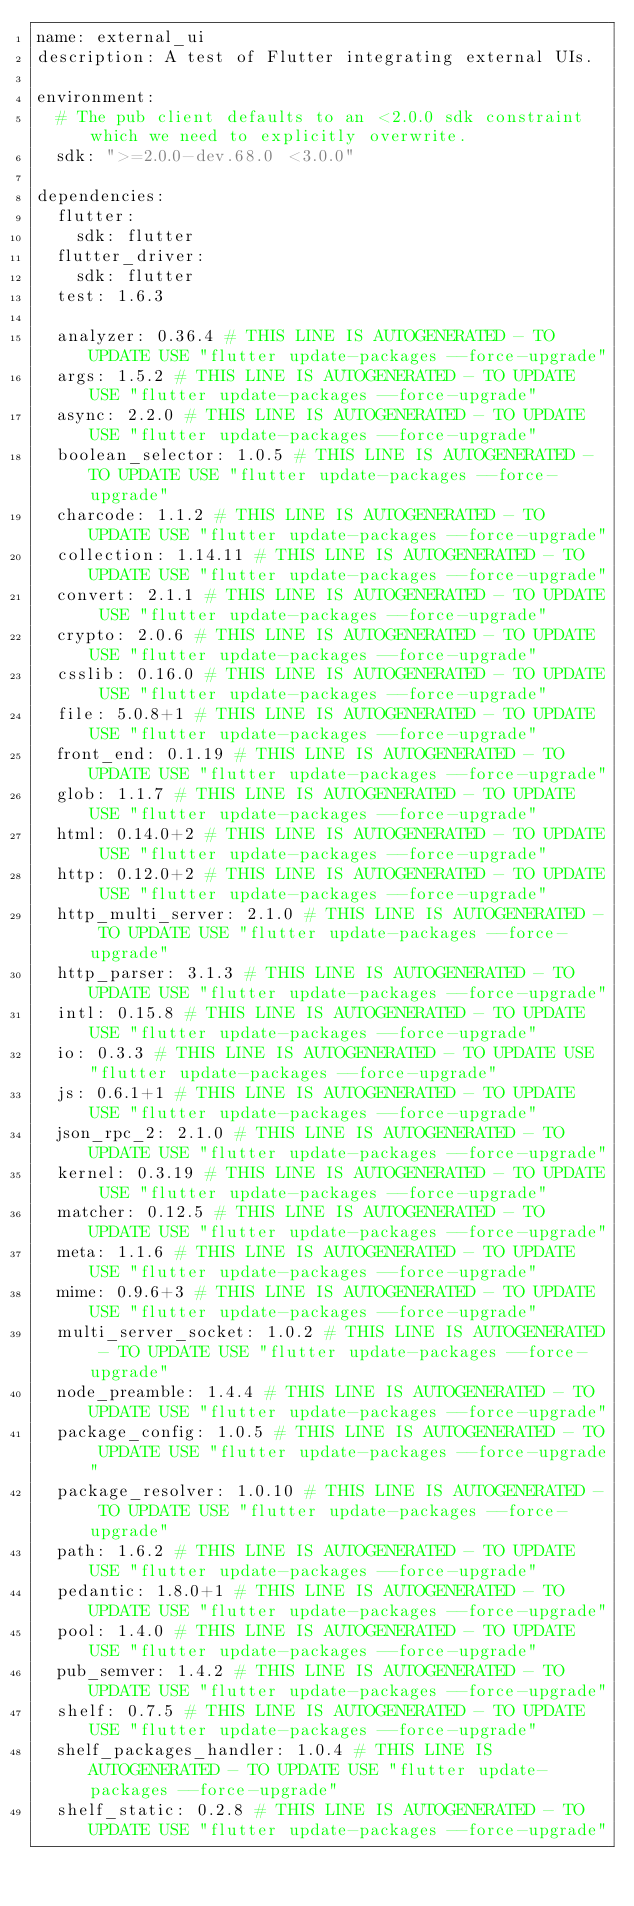<code> <loc_0><loc_0><loc_500><loc_500><_YAML_>name: external_ui
description: A test of Flutter integrating external UIs.

environment:
  # The pub client defaults to an <2.0.0 sdk constraint which we need to explicitly overwrite.
  sdk: ">=2.0.0-dev.68.0 <3.0.0"

dependencies:
  flutter:
    sdk: flutter
  flutter_driver:
    sdk: flutter
  test: 1.6.3

  analyzer: 0.36.4 # THIS LINE IS AUTOGENERATED - TO UPDATE USE "flutter update-packages --force-upgrade"
  args: 1.5.2 # THIS LINE IS AUTOGENERATED - TO UPDATE USE "flutter update-packages --force-upgrade"
  async: 2.2.0 # THIS LINE IS AUTOGENERATED - TO UPDATE USE "flutter update-packages --force-upgrade"
  boolean_selector: 1.0.5 # THIS LINE IS AUTOGENERATED - TO UPDATE USE "flutter update-packages --force-upgrade"
  charcode: 1.1.2 # THIS LINE IS AUTOGENERATED - TO UPDATE USE "flutter update-packages --force-upgrade"
  collection: 1.14.11 # THIS LINE IS AUTOGENERATED - TO UPDATE USE "flutter update-packages --force-upgrade"
  convert: 2.1.1 # THIS LINE IS AUTOGENERATED - TO UPDATE USE "flutter update-packages --force-upgrade"
  crypto: 2.0.6 # THIS LINE IS AUTOGENERATED - TO UPDATE USE "flutter update-packages --force-upgrade"
  csslib: 0.16.0 # THIS LINE IS AUTOGENERATED - TO UPDATE USE "flutter update-packages --force-upgrade"
  file: 5.0.8+1 # THIS LINE IS AUTOGENERATED - TO UPDATE USE "flutter update-packages --force-upgrade"
  front_end: 0.1.19 # THIS LINE IS AUTOGENERATED - TO UPDATE USE "flutter update-packages --force-upgrade"
  glob: 1.1.7 # THIS LINE IS AUTOGENERATED - TO UPDATE USE "flutter update-packages --force-upgrade"
  html: 0.14.0+2 # THIS LINE IS AUTOGENERATED - TO UPDATE USE "flutter update-packages --force-upgrade"
  http: 0.12.0+2 # THIS LINE IS AUTOGENERATED - TO UPDATE USE "flutter update-packages --force-upgrade"
  http_multi_server: 2.1.0 # THIS LINE IS AUTOGENERATED - TO UPDATE USE "flutter update-packages --force-upgrade"
  http_parser: 3.1.3 # THIS LINE IS AUTOGENERATED - TO UPDATE USE "flutter update-packages --force-upgrade"
  intl: 0.15.8 # THIS LINE IS AUTOGENERATED - TO UPDATE USE "flutter update-packages --force-upgrade"
  io: 0.3.3 # THIS LINE IS AUTOGENERATED - TO UPDATE USE "flutter update-packages --force-upgrade"
  js: 0.6.1+1 # THIS LINE IS AUTOGENERATED - TO UPDATE USE "flutter update-packages --force-upgrade"
  json_rpc_2: 2.1.0 # THIS LINE IS AUTOGENERATED - TO UPDATE USE "flutter update-packages --force-upgrade"
  kernel: 0.3.19 # THIS LINE IS AUTOGENERATED - TO UPDATE USE "flutter update-packages --force-upgrade"
  matcher: 0.12.5 # THIS LINE IS AUTOGENERATED - TO UPDATE USE "flutter update-packages --force-upgrade"
  meta: 1.1.6 # THIS LINE IS AUTOGENERATED - TO UPDATE USE "flutter update-packages --force-upgrade"
  mime: 0.9.6+3 # THIS LINE IS AUTOGENERATED - TO UPDATE USE "flutter update-packages --force-upgrade"
  multi_server_socket: 1.0.2 # THIS LINE IS AUTOGENERATED - TO UPDATE USE "flutter update-packages --force-upgrade"
  node_preamble: 1.4.4 # THIS LINE IS AUTOGENERATED - TO UPDATE USE "flutter update-packages --force-upgrade"
  package_config: 1.0.5 # THIS LINE IS AUTOGENERATED - TO UPDATE USE "flutter update-packages --force-upgrade"
  package_resolver: 1.0.10 # THIS LINE IS AUTOGENERATED - TO UPDATE USE "flutter update-packages --force-upgrade"
  path: 1.6.2 # THIS LINE IS AUTOGENERATED - TO UPDATE USE "flutter update-packages --force-upgrade"
  pedantic: 1.8.0+1 # THIS LINE IS AUTOGENERATED - TO UPDATE USE "flutter update-packages --force-upgrade"
  pool: 1.4.0 # THIS LINE IS AUTOGENERATED - TO UPDATE USE "flutter update-packages --force-upgrade"
  pub_semver: 1.4.2 # THIS LINE IS AUTOGENERATED - TO UPDATE USE "flutter update-packages --force-upgrade"
  shelf: 0.7.5 # THIS LINE IS AUTOGENERATED - TO UPDATE USE "flutter update-packages --force-upgrade"
  shelf_packages_handler: 1.0.4 # THIS LINE IS AUTOGENERATED - TO UPDATE USE "flutter update-packages --force-upgrade"
  shelf_static: 0.2.8 # THIS LINE IS AUTOGENERATED - TO UPDATE USE "flutter update-packages --force-upgrade"</code> 